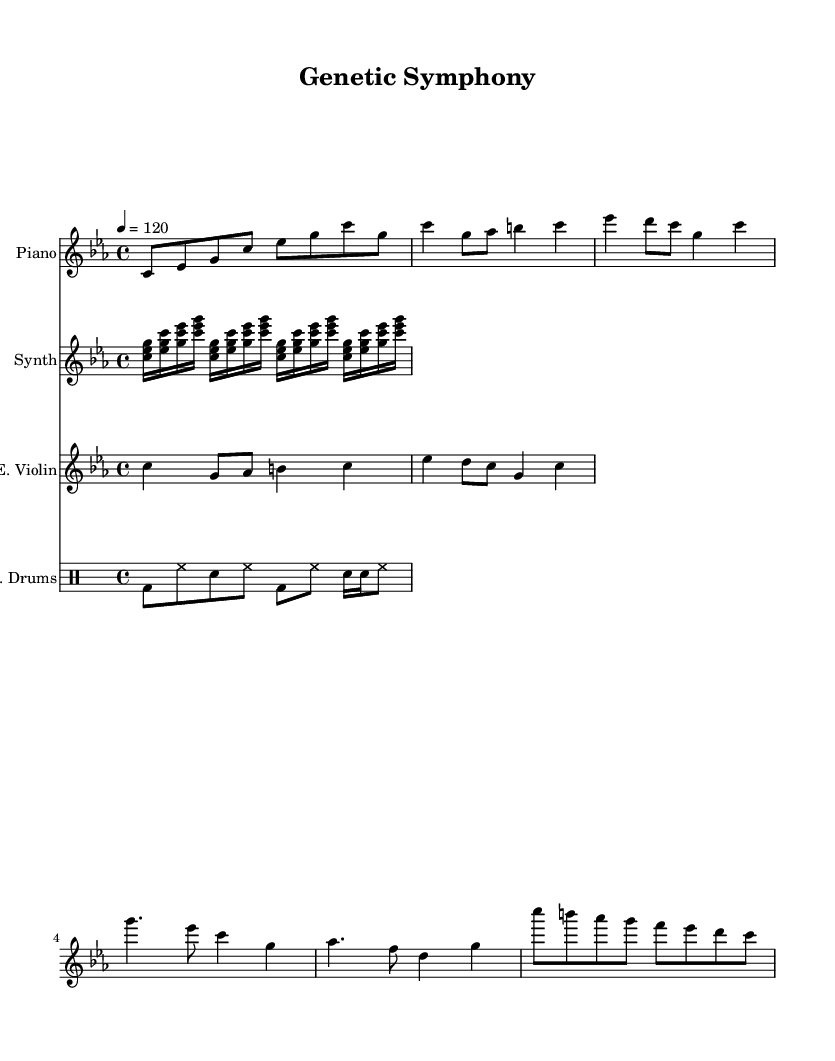What is the key signature of this music? The key signature is C minor, which includes three flats: B flat, E flat, and A flat. This is indicated at the beginning of the staff in the sheet music.
Answer: C minor What is the time signature of the music? The time signature is 4/4, which means there are four beats in each measure and a quarter note receives one beat. This is also shown at the beginning of the score.
Answer: 4/4 What is the tempo marking in the music? The tempo marking is given as quarter note equals 120, meaning the quarter note is played at 120 beats per minute. This information is also stated at the beginning of the sheet music.
Answer: 120 How many different instruments are used in this piece? The score includes four distinct instruments: Piano, Synth, Electric Violin, and Electric Drums. Each is indicated on a separate staff.
Answer: Four What type of musical pattern is represented by the synth part? The synth part consists of an arpeggiated pattern that represents DNA sequences, indicated by the repeated chords played in a rapid succession.
Answer: Arpeggiated pattern What musical elements are present in the electronic drum pattern? The electronic drum pattern features a mix of bass drum, hi-hat, and snare drum, with a glitch-like effect inferred from the rhythm and note density. This diversity of sounds characterizes electronic music.
Answer: Glitch-like effects What is the form of this composition? The composition has a structure that includes an Intro, Verse, Chorus, and Bridge, which are indicated by the different sections of the piano music. This typical pop music format creates a sense of progression.
Answer: Intro, Verse, Chorus, Bridge 